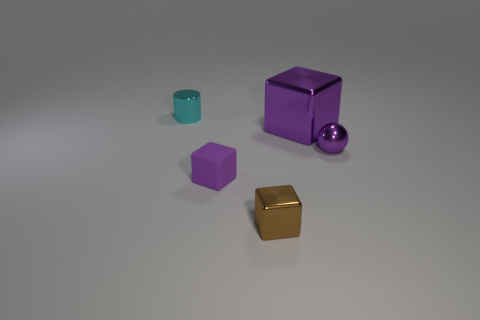There is another small thing that is the same shape as the tiny brown shiny object; what material is it?
Give a very brief answer. Rubber. How many other objects are the same size as the purple shiny ball?
Your response must be concise. 3. What is the material of the large block?
Your answer should be very brief. Metal. Are there more cyan things in front of the small cyan cylinder than purple balls?
Provide a succinct answer. No. Are there any cyan shiny objects?
Provide a succinct answer. Yes. How many other things are the same shape as the cyan thing?
Keep it short and to the point. 0. Is the color of the object that is behind the big purple thing the same as the metal block to the left of the purple metallic cube?
Provide a succinct answer. No. What is the size of the purple block that is in front of the purple cube that is behind the tiny purple object on the left side of the tiny brown metal block?
Your answer should be very brief. Small. What is the shape of the small metal thing that is on the left side of the large object and in front of the cyan metallic thing?
Provide a succinct answer. Cube. Are there an equal number of small purple blocks behind the small cyan shiny cylinder and brown blocks that are left of the purple matte cube?
Your answer should be compact. Yes. 